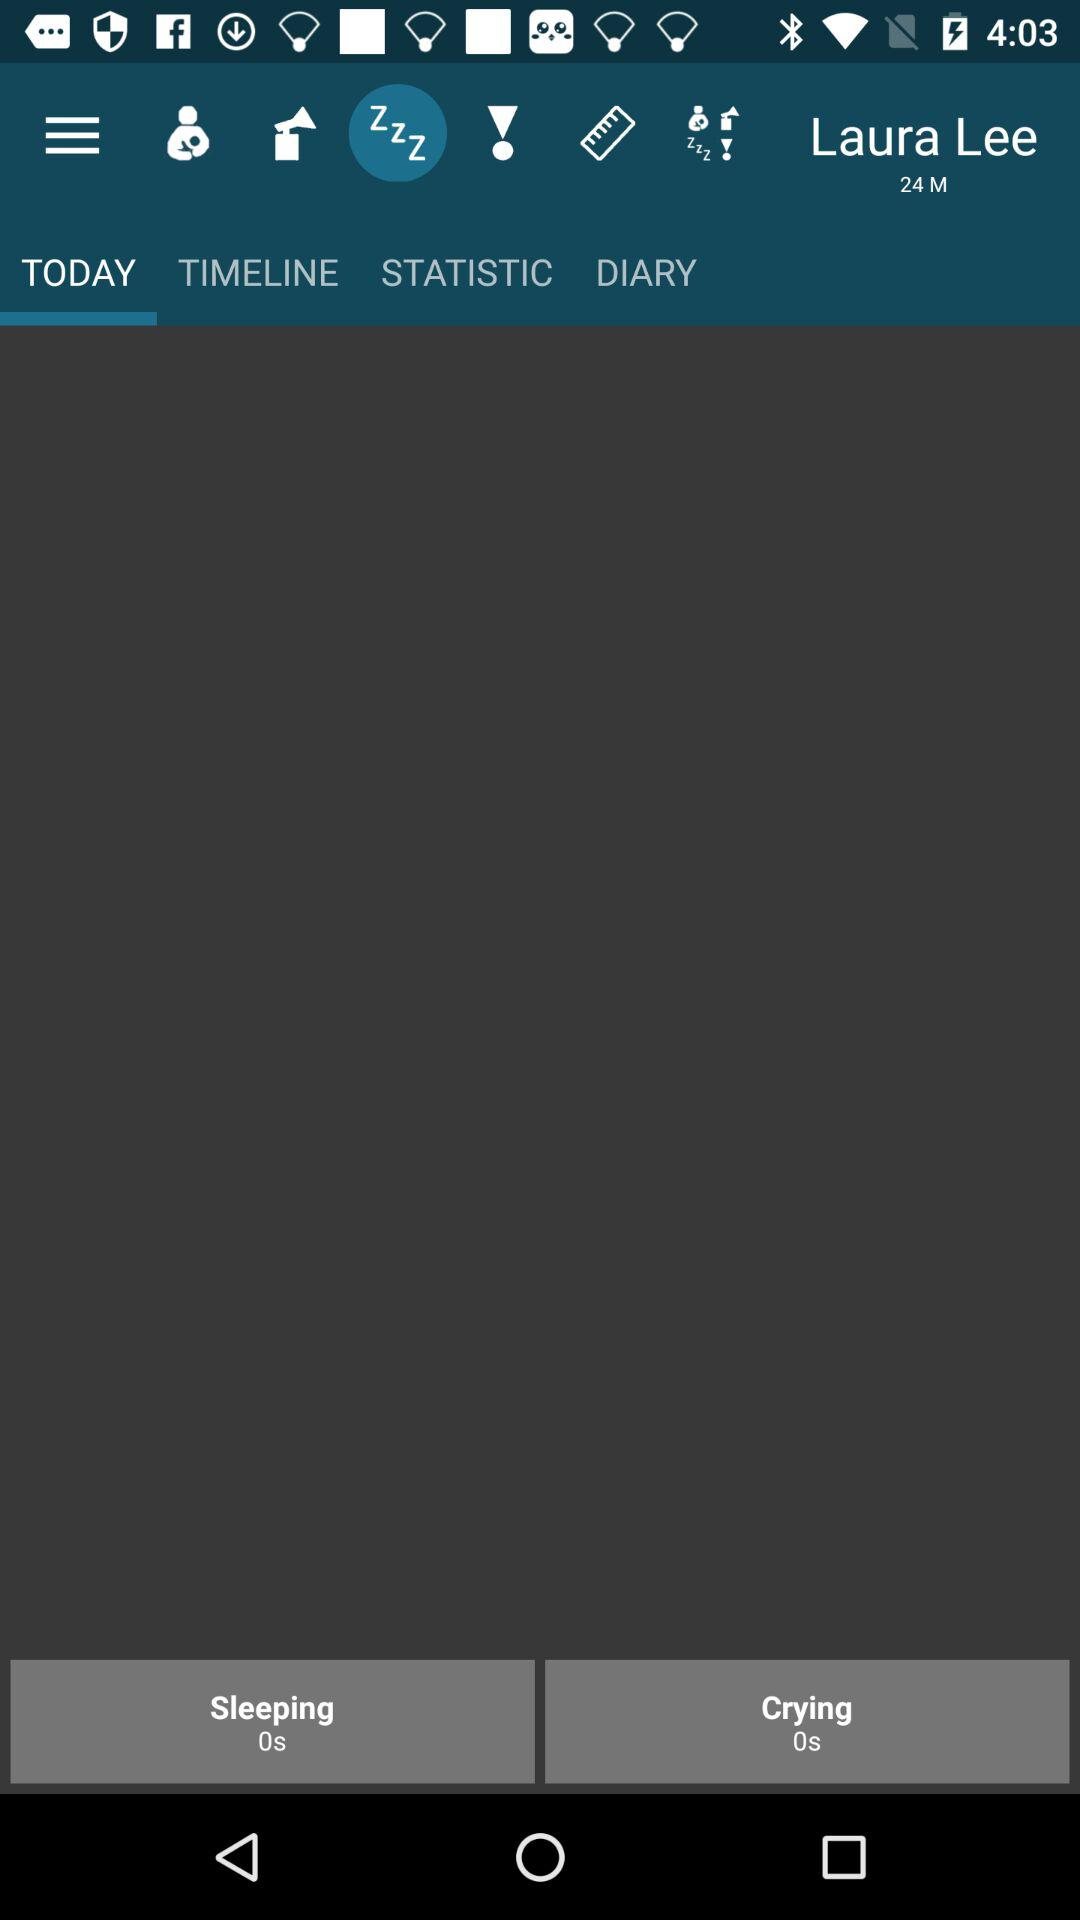What is the user name? The user name is Laura Lee. 